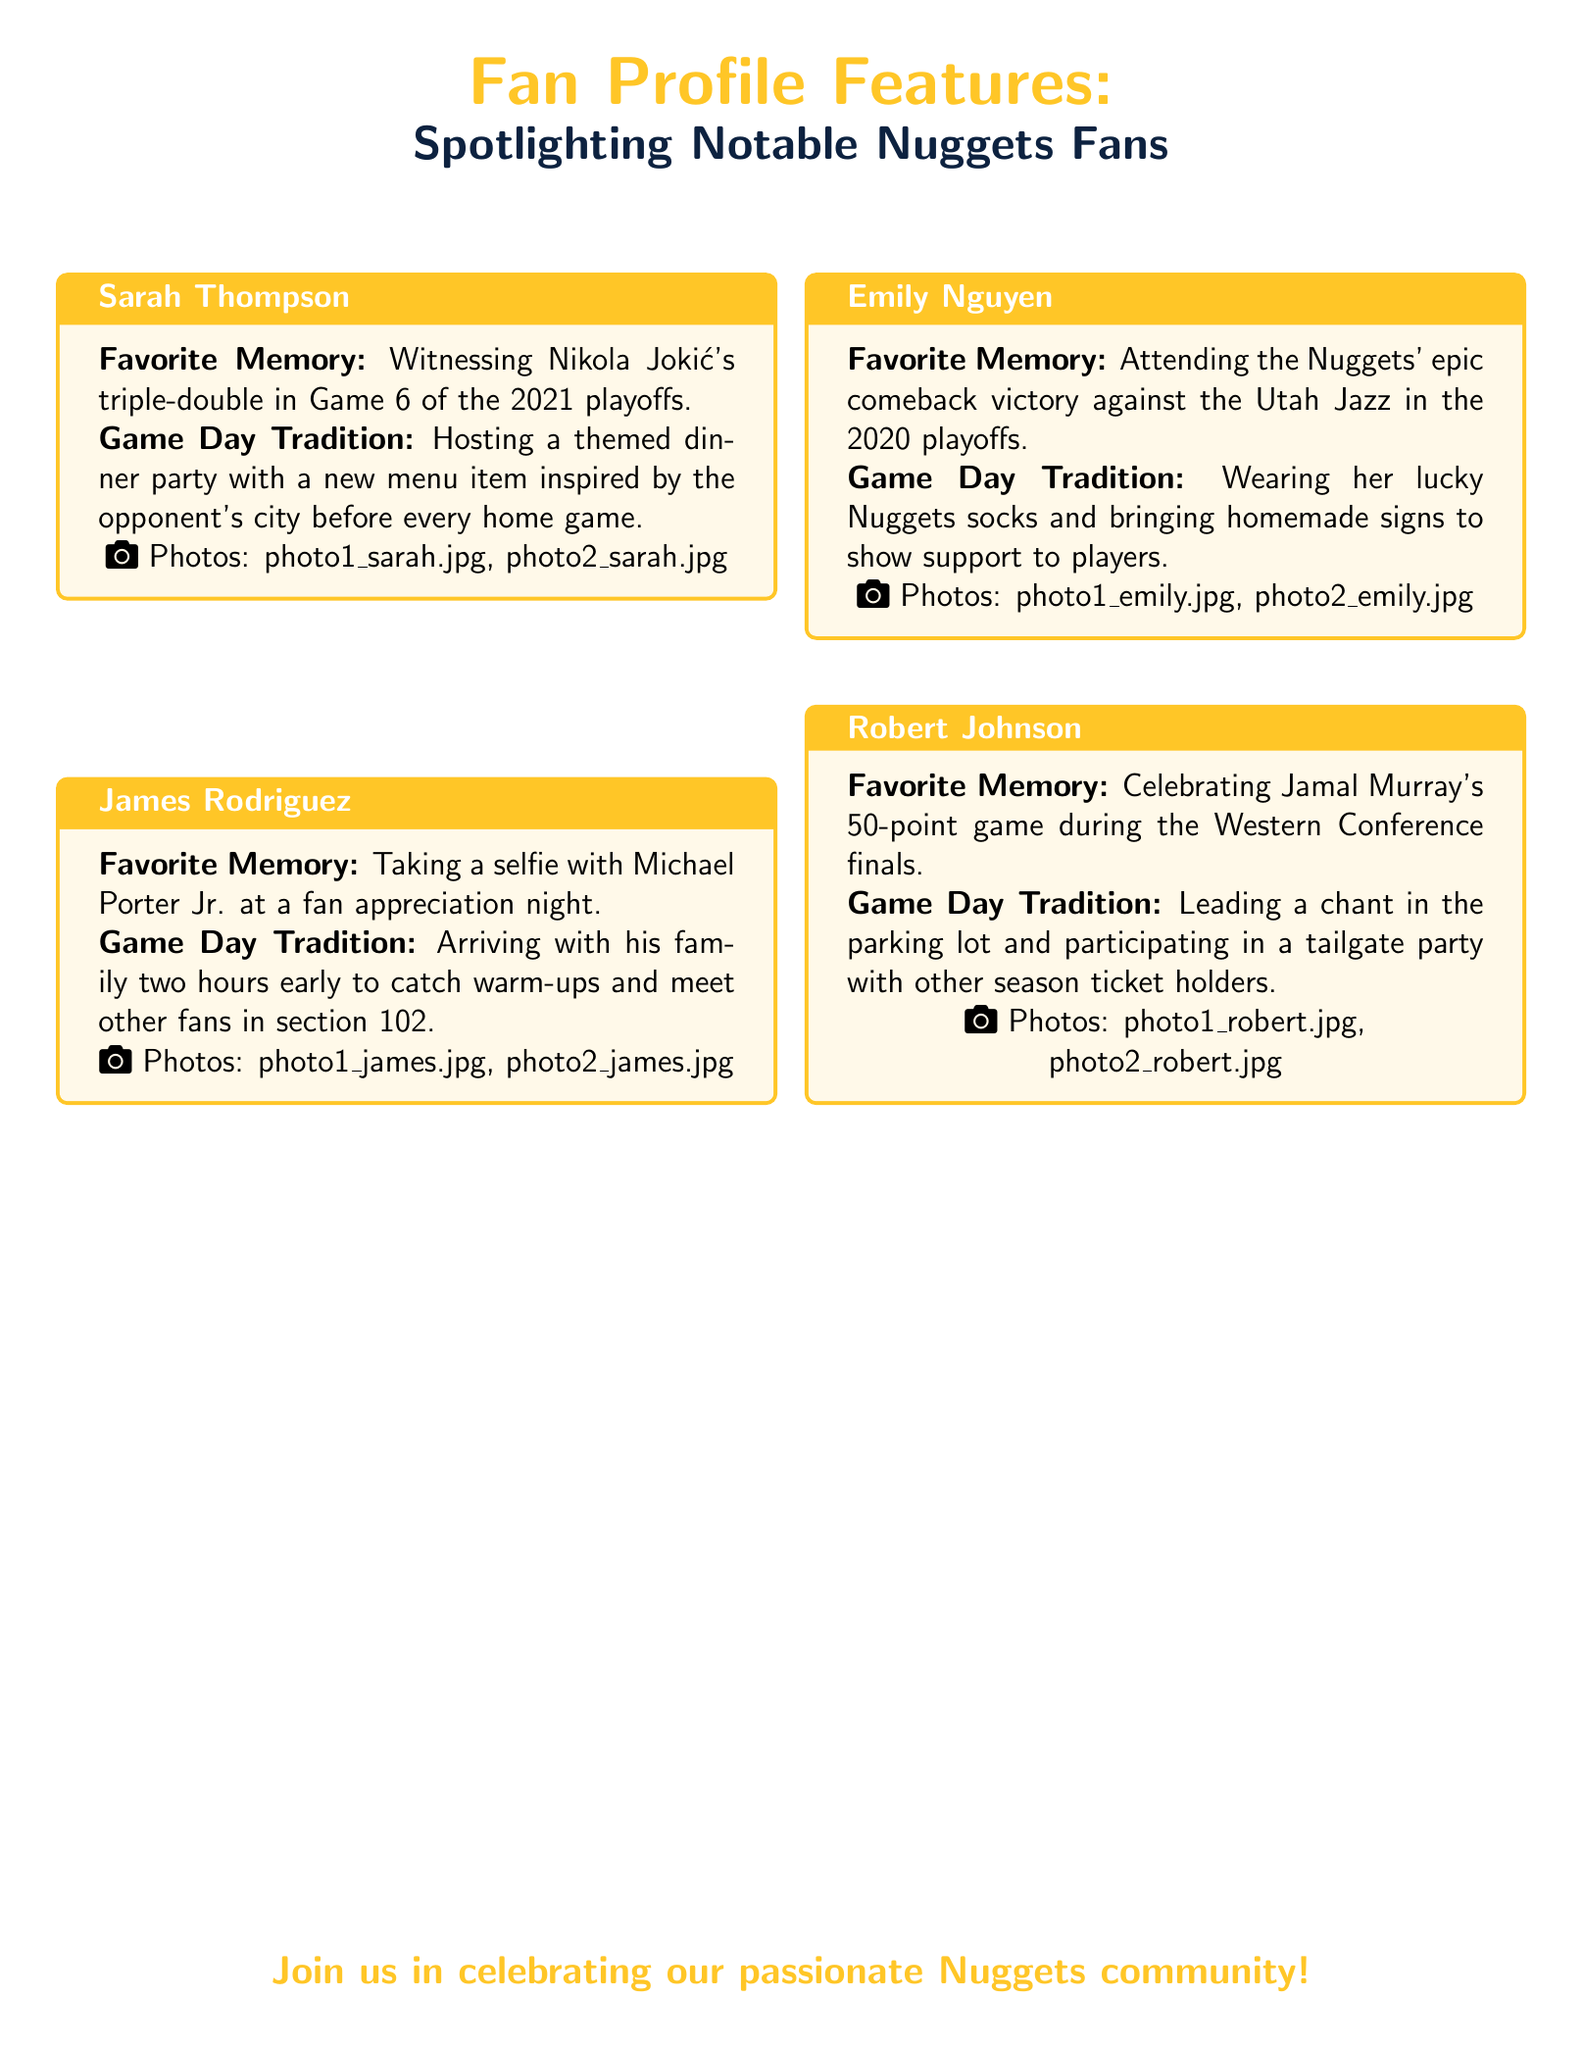What is Sarah Thompson's favorite memory? Sarah Thompson's favorite memory is detailed in her profile in the document.
Answer: Witnessing Nikola Jokić's triple-double in Game 6 of the 2021 playoffs What unique game day tradition does James Rodriguez have? James Rodriguez's tradition involves a specific activity he does before games, mentioned in his profile.
Answer: Arriving with his family two hours early to catch warm-ups How many photos are associated with Emily Nguyen's profile? The number of photos is mentioned in Emily Nguyen's profile section.
Answer: 2 What was Robert Johnson celebrating during the Western Conference finals? Robert Johnson's celebration event is explicitly mentioned in his profile in the document.
Answer: Jamal Murray's 50-point game Which fan took a selfie with Michael Porter Jr.? The fan's name who took a selfie with Michael Porter Jr. is specified in the document.
Answer: James Rodriguez What color are the header texts in the Playbill? The color of the headings is described in the document's styling.
Answer: Nuggets gold What type of event does Sarah Thompson host before each home game? The event is indicated in her game day tradition, discussed in her profile.
Answer: A themed dinner party Which player's comeback victory did Emily Nguyen attend? The specific team and event related to Emily Nguyen's favorite memory is detailed.
Answer: Utah Jazz 